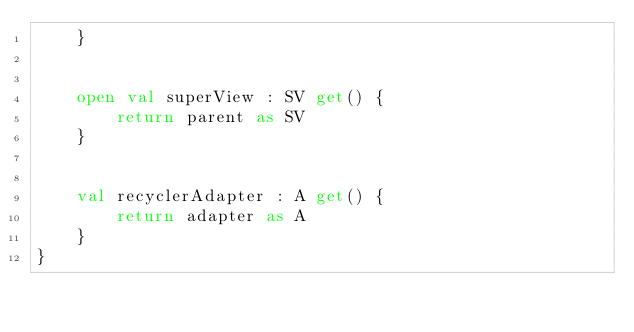Convert code to text. <code><loc_0><loc_0><loc_500><loc_500><_Kotlin_>    }


    open val superView : SV get() {
        return parent as SV
    }


    val recyclerAdapter : A get() {
        return adapter as A
    }
}</code> 